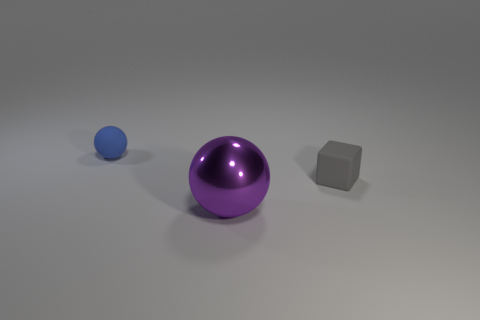There is a rubber cube; is its size the same as the thing behind the gray matte block?
Offer a very short reply. Yes. What color is the matte object that is the same size as the block?
Give a very brief answer. Blue. What size is the metallic ball?
Offer a very short reply. Large. Does the purple thing that is to the right of the blue matte object have the same material as the tiny gray thing?
Provide a short and direct response. No. Is the blue matte object the same shape as the big purple metal thing?
Your response must be concise. Yes. The matte thing to the right of the tiny rubber object to the left of the tiny rubber thing to the right of the tiny blue rubber sphere is what shape?
Make the answer very short. Cube. Is the shape of the rubber thing behind the gray thing the same as the thing in front of the gray matte thing?
Provide a succinct answer. Yes. Is there a cyan cube made of the same material as the big purple object?
Give a very brief answer. No. The object in front of the tiny matte thing that is in front of the ball behind the small cube is what color?
Ensure brevity in your answer.  Purple. Are the blue object that is behind the purple sphere and the big purple object that is on the left side of the gray matte object made of the same material?
Your answer should be compact. No. 